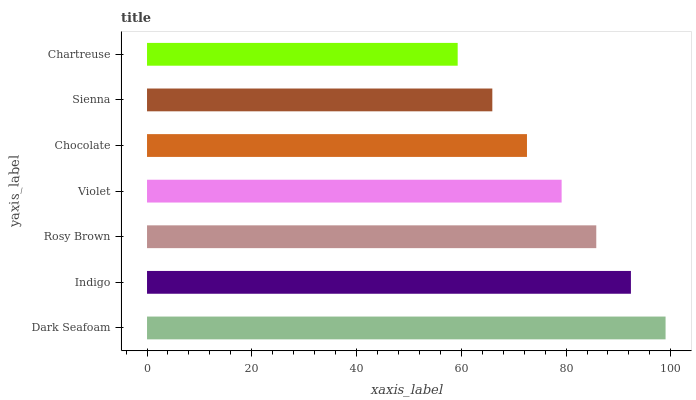Is Chartreuse the minimum?
Answer yes or no. Yes. Is Dark Seafoam the maximum?
Answer yes or no. Yes. Is Indigo the minimum?
Answer yes or no. No. Is Indigo the maximum?
Answer yes or no. No. Is Dark Seafoam greater than Indigo?
Answer yes or no. Yes. Is Indigo less than Dark Seafoam?
Answer yes or no. Yes. Is Indigo greater than Dark Seafoam?
Answer yes or no. No. Is Dark Seafoam less than Indigo?
Answer yes or no. No. Is Violet the high median?
Answer yes or no. Yes. Is Violet the low median?
Answer yes or no. Yes. Is Dark Seafoam the high median?
Answer yes or no. No. Is Sienna the low median?
Answer yes or no. No. 